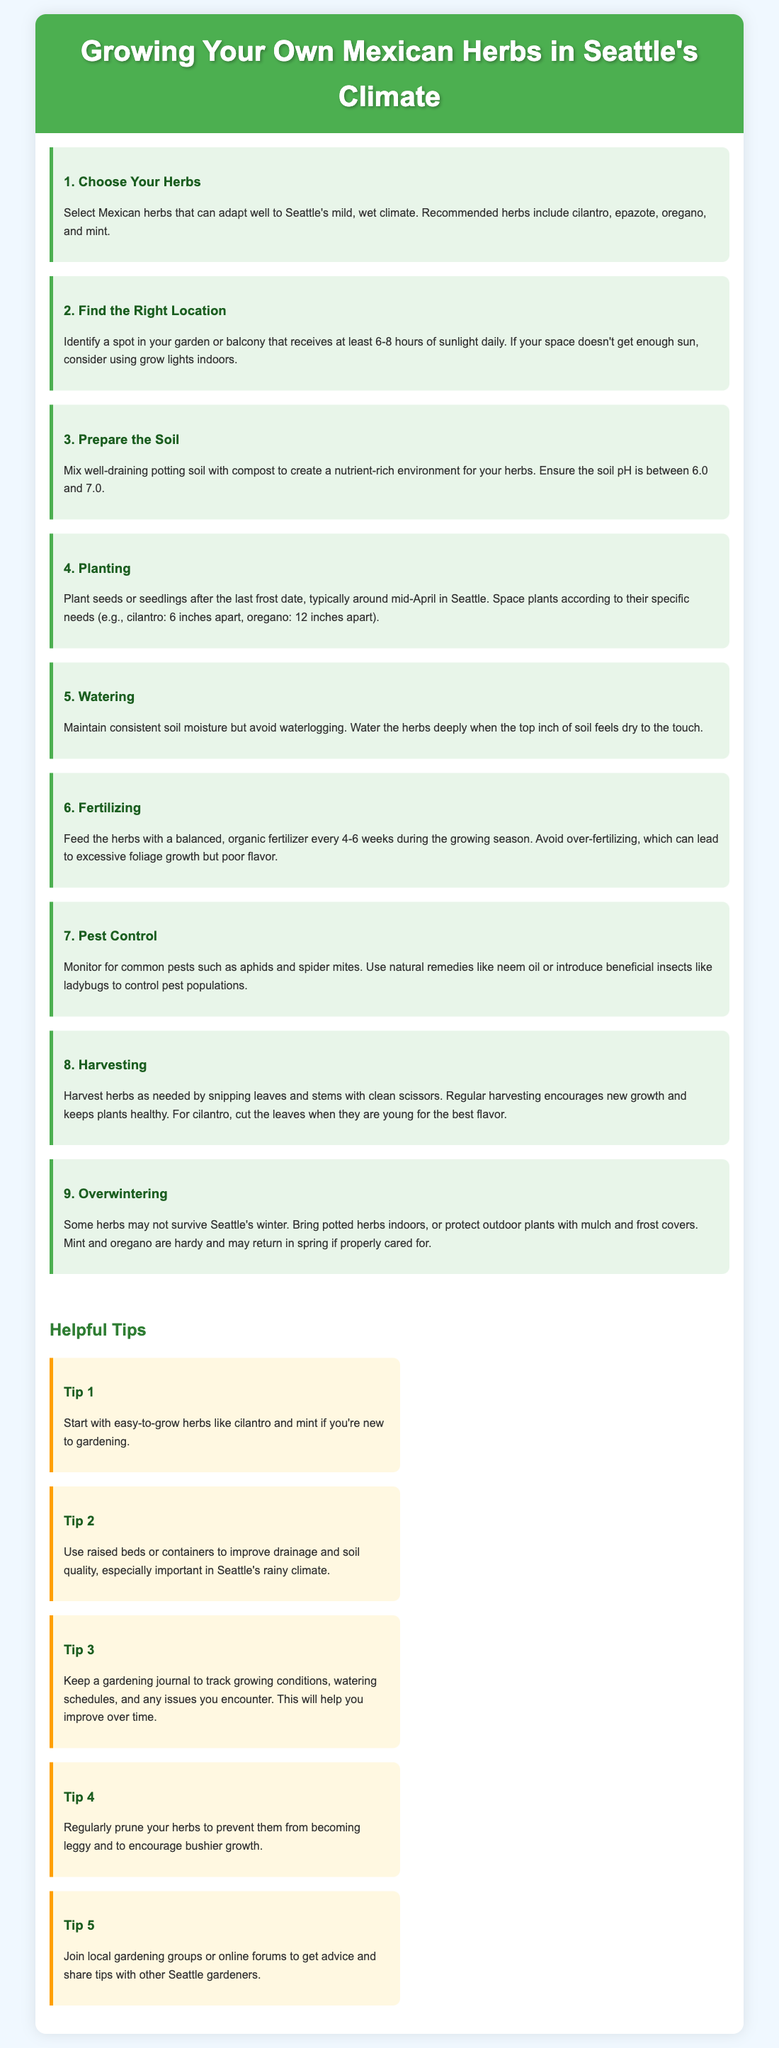What are some recommended Mexican herbs for Seattle's climate? The document lists cilantro, epazote, oregano, and mint as recommended herbs that can adapt well to Seattle's climate.
Answer: cilantro, epazote, oregano, mint How many hours of sunlight should your herbs receive daily? The document states that herbs should receive at least 6-8 hours of sunlight daily for optimal growth.
Answer: 6-8 hours When should you plant seeds or seedlings in Seattle? According to the document, you should plant after the last frost date, typically around mid-April in Seattle.
Answer: mid-April What is the soil pH range recommended for growing Mexican herbs? The document recommends that the soil pH should be between 6.0 and 7.0 for optimal growth of herbs.
Answer: 6.0 and 7.0 What should you do to pest control? The document advises monitoring for pests and using natural remedies like neem oil or introducing beneficial insects like ladybugs.
Answer: Monitor pests, use neem oil or ladybugs Why is regular harvesting important? The document explains that regular harvesting encourages new growth and keeps plants healthy, especially for herbs like cilantro.
Answer: Encourages new growth What is one method to improve soil quality in Seattle? The document suggests using raised beds or containers to improve drainage and soil quality, which is important in Seattle's climate.
Answer: Raised beds or containers How often should you fertilize your herbs during the growing season? The document states that you should feed the herbs with a balanced, organic fertilizer every 4-6 weeks during the growing season.
Answer: Every 4-6 weeks What is the benefit of keeping a gardening journal? The document mentions that keeping a gardening journal helps track growing conditions and issues, allowing for improvement over time.
Answer: Track growing conditions What can you do to protect outdoor plants in the winter? The document advises bringing potted herbs indoors or protecting outdoor plants with mulch and frost covers during winter.
Answer: Bring indoors or use mulch and frost covers 